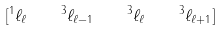Convert formula to latex. <formula><loc_0><loc_0><loc_500><loc_500>[ ^ { 1 } \ell _ { \ell } \quad ^ { 3 } \ell _ { \ell - 1 } \quad ^ { 3 } \ell _ { \ell } \quad ^ { 3 } \ell _ { \ell + 1 } ]</formula> 